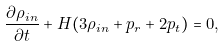Convert formula to latex. <formula><loc_0><loc_0><loc_500><loc_500>\frac { \partial \rho _ { i n } } { \partial t } + H ( 3 \rho _ { i n } + p _ { r } + 2 p _ { t } ) = 0 ,</formula> 